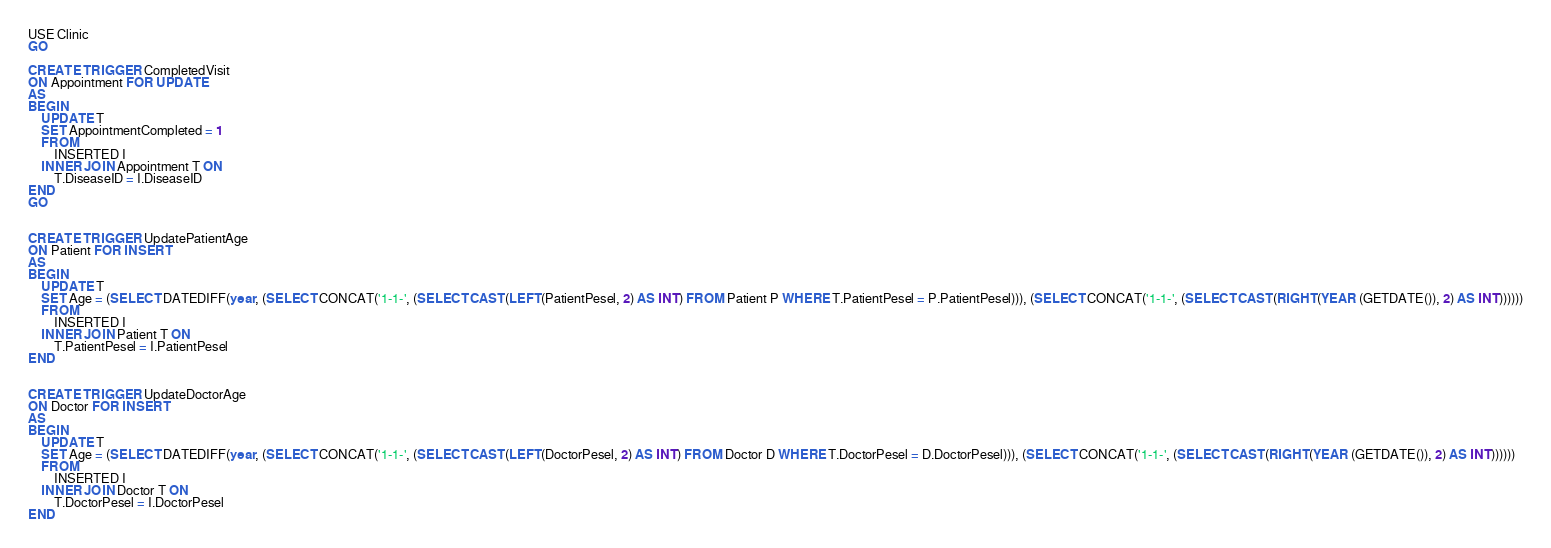Convert code to text. <code><loc_0><loc_0><loc_500><loc_500><_SQL_>USE Clinic
GO

CREATE TRIGGER CompletedVisit
ON Appointment FOR UPDATE
AS
BEGIN
    UPDATE T
    SET AppointmentCompleted = 1
    FROM
        INSERTED I
    INNER JOIN Appointment T ON
        T.DiseaseID = I.DiseaseID
END
GO


CREATE TRIGGER UpdatePatientAge
ON Patient FOR INSERT
AS
BEGIN
    UPDATE T
    SET Age = (SELECT DATEDIFF(year, (SELECT CONCAT('1-1-', (SELECT CAST(LEFT(PatientPesel, 2) AS INT) FROM Patient P WHERE T.PatientPesel = P.PatientPesel))), (SELECT CONCAT('1-1-', (SELECT CAST(RIGHT(YEAR (GETDATE()), 2) AS INT))))))
    FROM
        INSERTED I
    INNER JOIN Patient T ON
        T.PatientPesel = I.PatientPesel
END


CREATE TRIGGER UpdateDoctorAge
ON Doctor FOR INSERT
AS
BEGIN
    UPDATE T
    SET Age = (SELECT DATEDIFF(year, (SELECT CONCAT('1-1-', (SELECT CAST(LEFT(DoctorPesel, 2) AS INT) FROM Doctor D WHERE T.DoctorPesel = D.DoctorPesel))), (SELECT CONCAT('1-1-', (SELECT CAST(RIGHT(YEAR (GETDATE()), 2) AS INT))))))
    FROM
        INSERTED I
    INNER JOIN Doctor T ON
        T.DoctorPesel = I.DoctorPesel
END</code> 